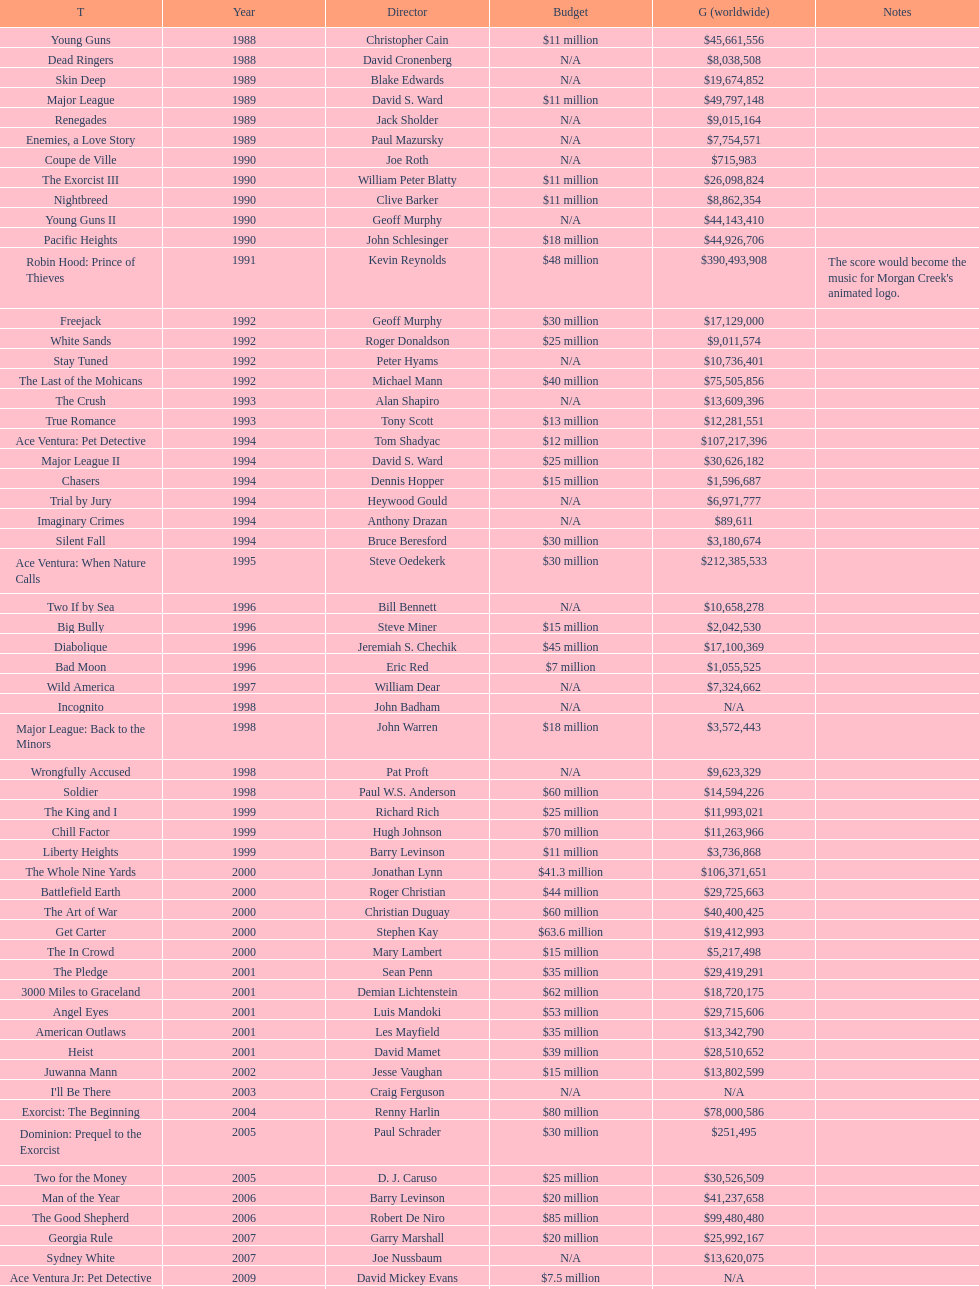How many films did morgan creek make in 2006? 2. 